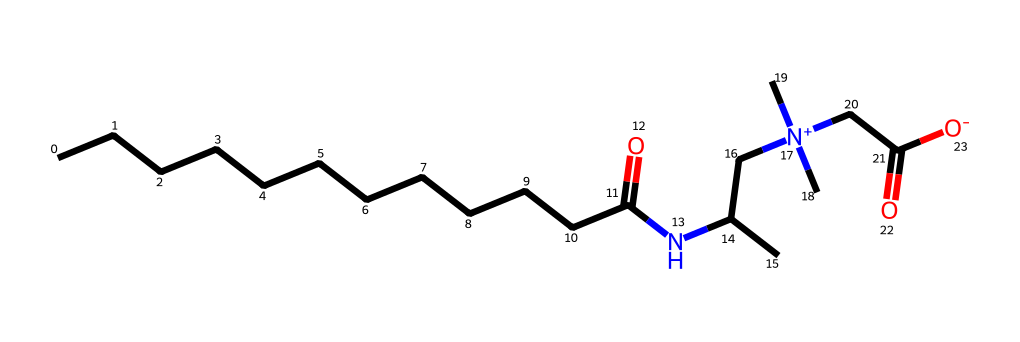What is the main functional group present in cocamidopropyl betaine? The main functional group in cocamidopropyl betaine is the quaternary ammonium group, as indicated by the nitrogen atom bonded to four carbon chains.
Answer: quaternary ammonium group How many carbon atoms are in cocamidopropyl betaine? By inspecting the structure, there are a total of 16 carbon atoms present, as identified in the long carbon chains and those directly attached to the nitrogen.
Answer: 16 What type of surfactant is cocamidopropyl betaine? Cocamidopropyl betaine is classified as an amphoteric surfactant because it can carry both positive and negative charges depending on the pH.
Answer: amphoteric surfactant What is the total number of nitrogen atoms in cocamidopropyl betaine? The structure shows two nitrogen atoms; one in the quaternary ammonium part and the other in the amide bond.
Answer: 2 What does the presence of the carboxylate group indicate about cocamidopropyl betaine? The carboxylate group, indicated by the presence of a carbon atom double-bonded to an oxygen (carbonyl) and negatively charged oxygen, suggests that this compound can interact well with water and further emphasizes its surfactant properties.
Answer: water-soluble How does the structure of cocamidopropyl betaine contribute to its surfactant properties? The long hydrocarbon chain provides lipophilic properties while the quaternary ammonium and carboxylate groups provide hydrophilic characteristics, allowing the molecule to effectively reduce surface tension and act as a surfactant.
Answer: reduces surface tension 